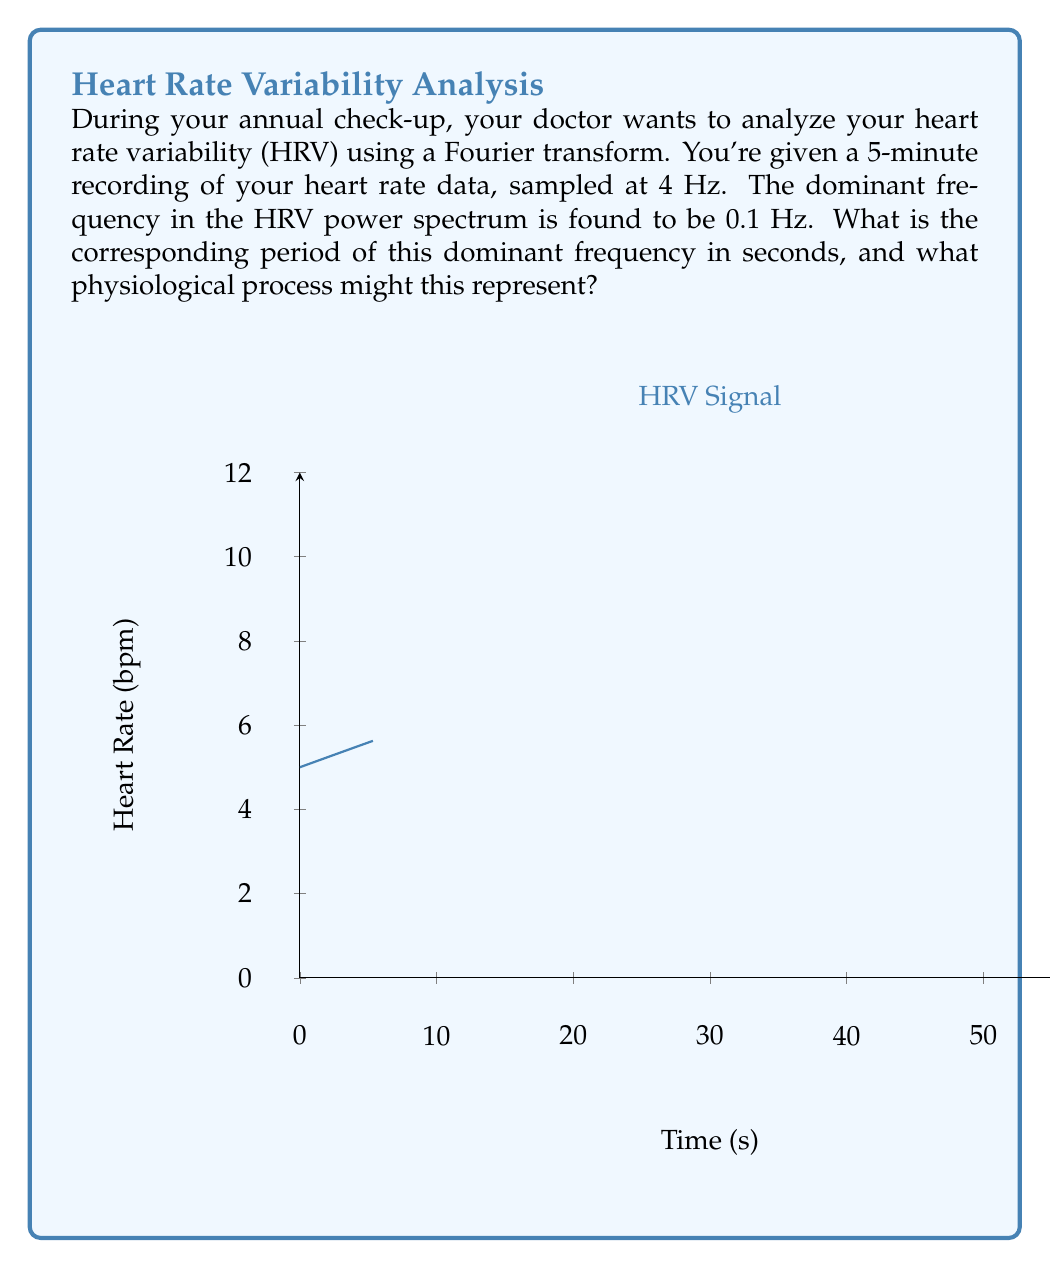Could you help me with this problem? To solve this problem, let's follow these steps:

1) The dominant frequency is given as 0.1 Hz. To find the period, we use the relationship:

   $$ T = \frac{1}{f} $$

   Where T is the period and f is the frequency.

2) Substituting the given frequency:

   $$ T = \frac{1}{0.1 \text{ Hz}} = 10 \text{ seconds} $$

3) The physiological interpretation of this 10-second cycle relates to the baroreflex, which is part of the body's blood pressure regulation mechanism.

4) The baroreflex operates on a roughly 10-second cycle, causing slight variations in heart rate that correspond to blood pressure fluctuations.

5) This low-frequency component (around 0.1 Hz) in HRV is often associated with both sympathetic and parasympathetic nervous system activity, particularly related to blood pressure regulation.

6) It's worth noting that while we're focusing on the dominant frequency, a full HRV analysis would typically consider multiple frequency bands:
   - Very Low Frequency (VLF): 0.003-0.04 Hz
   - Low Frequency (LF): 0.04-0.15 Hz (our 0.1 Hz falls here)
   - High Frequency (HF): 0.15-0.4 Hz

7) The presence of a strong 0.1 Hz component suggests normal baroreflex function, which is a positive sign for cardiovascular health.
Answer: 10 seconds; baroreflex cycle 